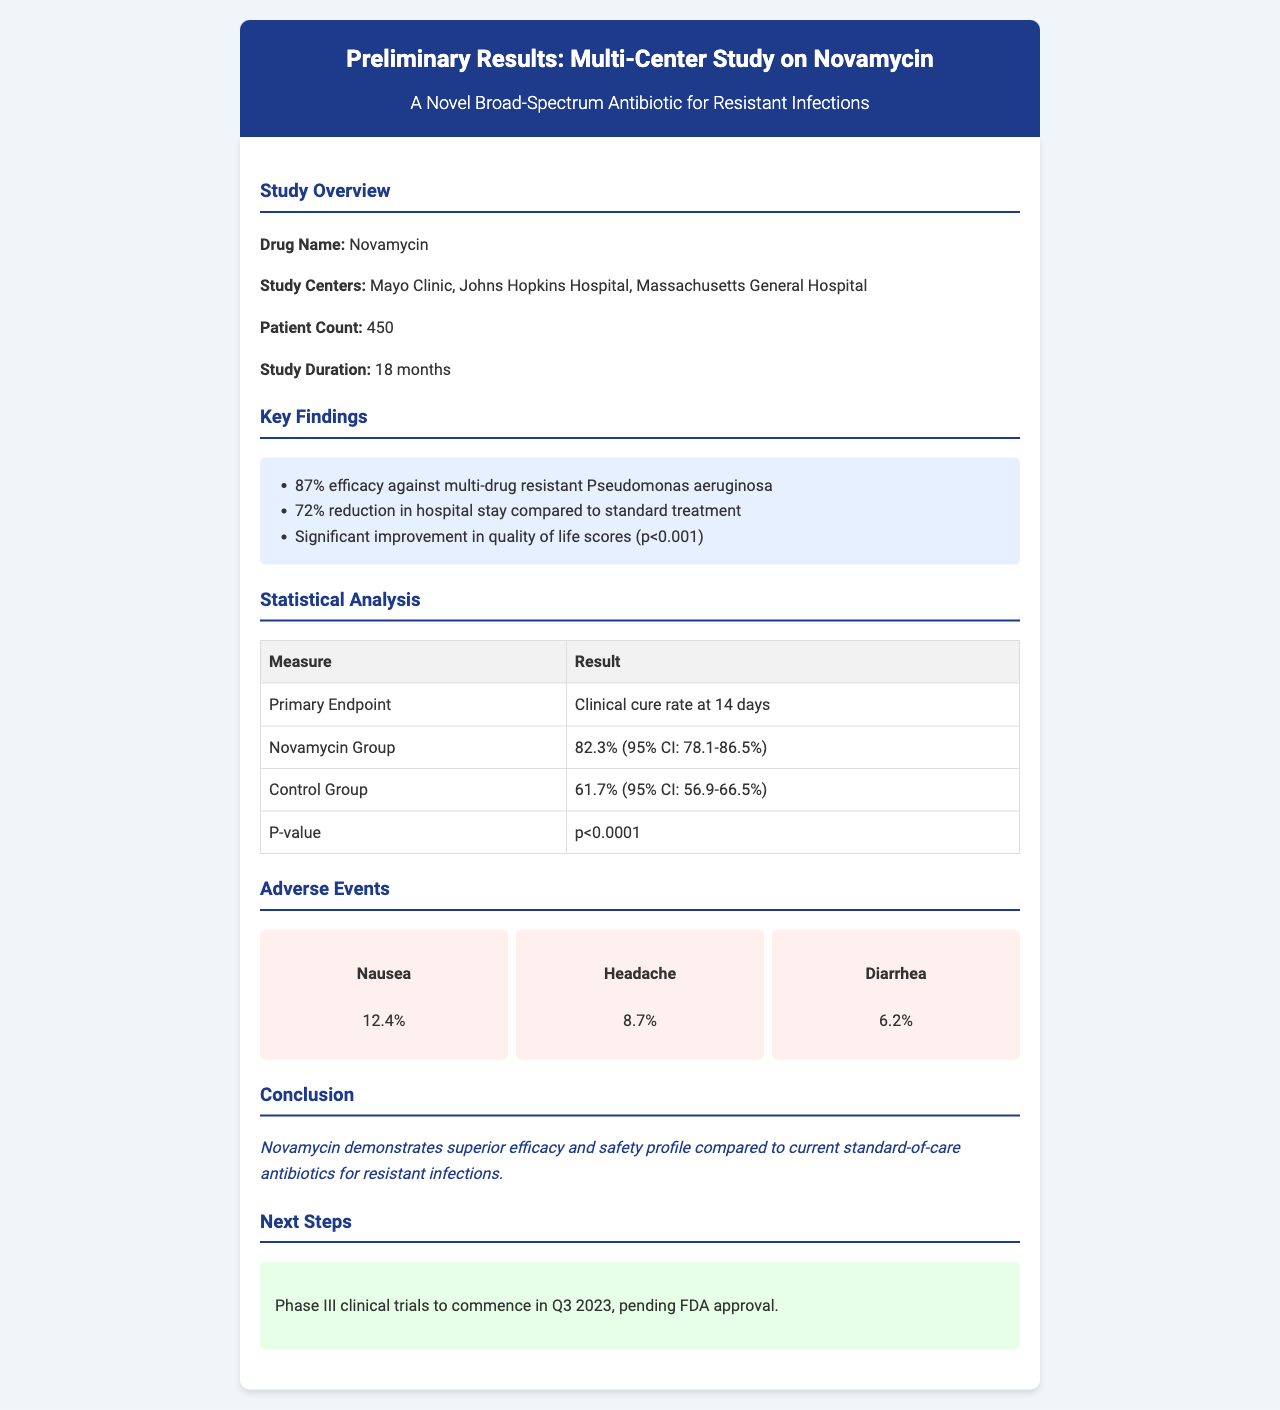what is the name of the drug studied in the trial? The document specifically states the drug being studied is Novamycin.
Answer: Novamycin how many patient centers were involved in the study? The document lists three study centers: Mayo Clinic, Johns Hopkins Hospital, and Massachusetts General Hospital.
Answer: 3 what was the patient count in the study? The document clearly indicates the total number of patients involved in the study.
Answer: 450 what is the efficacy percentage against multi-drug resistant Pseudomonas aeruginosa? The key findings section states that efficacy is 87%.
Answer: 87% what was the primary endpoint measure? The statistical analysis section reveals that the primary endpoint is the clinical cure rate at 14 days.
Answer: Clinical cure rate at 14 days what is the P-value indicating the significance of the results? The document states that the P-value is less than 0.0001, indicating strong significance.
Answer: p<0.0001 which adverse event reported the highest percentage? The adverse events section lists nausea as the most common adverse event occurring in 12.4% of patients.
Answer: Nausea what is the conclusion about Novamycin's efficacy? The conclusion section summarizes that Novamycin has superior efficacy compared to current antibiotics.
Answer: Superior efficacy when are the Phase III clinical trials expected to commence? The next steps section notes that Phase III clinical trials are planned to start in Q3 2023.
Answer: Q3 2023 